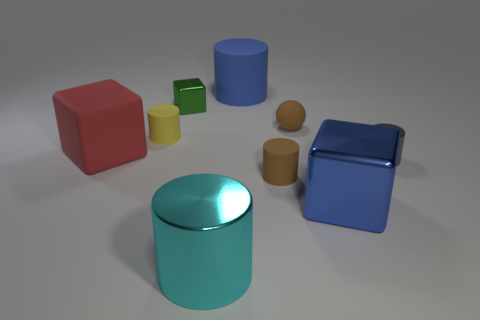Are there an equal number of big rubber cylinders in front of the large blue block and cylinders to the right of the cyan shiny thing?
Offer a terse response. No. What number of green objects are right of the large cyan metallic cylinder?
Offer a very short reply. 0. What number of things are either rubber balls or big blocks?
Offer a very short reply. 3. What number of metallic cylinders have the same size as the blue matte cylinder?
Provide a succinct answer. 1. There is a big blue object that is on the right side of the blue thing behind the gray shiny cylinder; what is its shape?
Keep it short and to the point. Cube. Are there fewer large yellow spheres than cyan metal objects?
Ensure brevity in your answer.  Yes. What color is the big block right of the big blue cylinder?
Make the answer very short. Blue. What material is the large object that is both to the right of the small green metal object and behind the blue cube?
Your answer should be very brief. Rubber. There is a blue thing that is made of the same material as the small green thing; what shape is it?
Provide a succinct answer. Cube. What number of red rubber objects are left of the big metal object that is to the left of the tiny ball?
Provide a succinct answer. 1. 